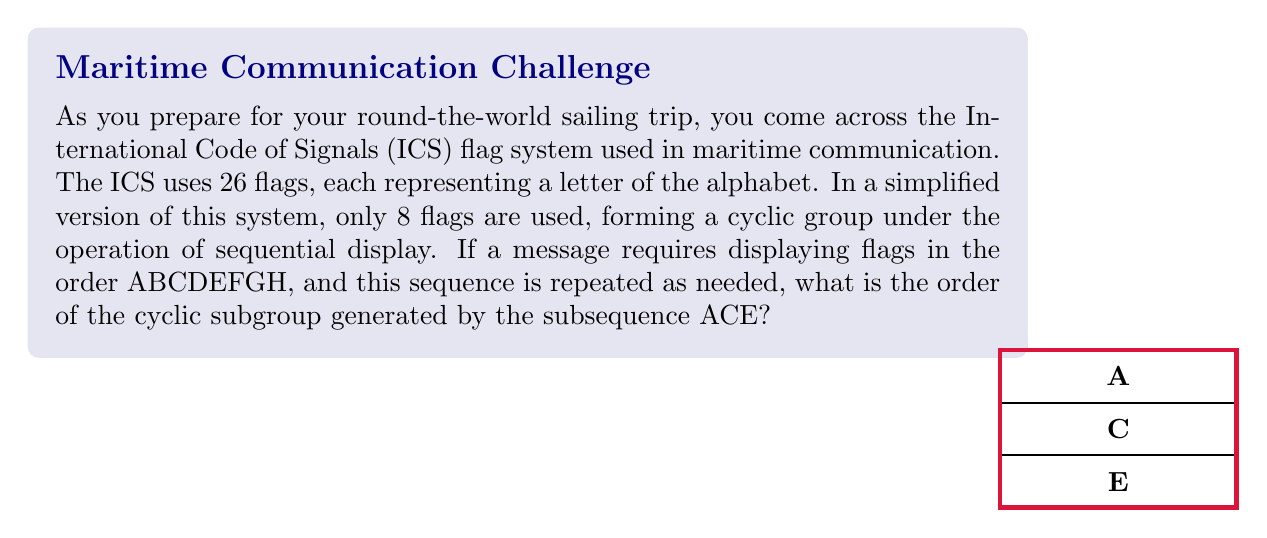Show me your answer to this math problem. Let's approach this step-by-step:

1) First, we need to understand what a cyclic subgroup is. In abstract algebra, a cyclic subgroup is a subgroup that can be generated by a single element of the group.

2) In this case, our main group is the cyclic group of order 8, represented by the sequence ABCDEFGH. We can denote this group as $C_8$.

3) The subsequence ACE generates a cyclic subgroup. Let's call this generator $g = ACE$.

4) To find the order of this subgroup, we need to determine how many times we need to apply $g$ to itself to get back to the identity element (which in this case is the empty sequence).

5) Let's apply $g$ repeatedly:
   $g^1 = ACE$
   $g^2 = ACEACE = ABCDEF$
   $g^3 = ACEACEACE = ABCDEFABC$
   $g^4 = ACEACEACEACE = ABCDEFGHABCDEF$

6) We can see that $g^4$ ends with ABCDEF, which means the next application of $g$ will start a new cycle.

7) Indeed, $g^8 = (ABCDEFGH)^3 = $ identity

8) Therefore, the order of the cyclic subgroup generated by ACE is 8.

9) We can also arrive at this conclusion algebraically. In $C_8$, the element ACE corresponds to a rotation by $\frac{3}{8}$ of a full turn. The order of this element is the smallest positive integer $n$ such that $\frac{3n}{8} \equiv 0 \pmod{1}$, which is 8.
Answer: 8 